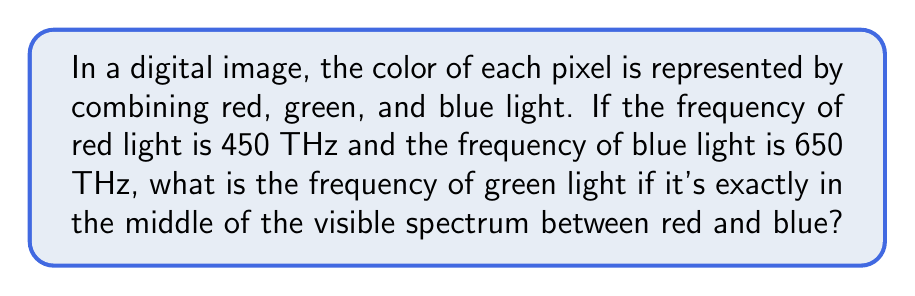What is the answer to this math problem? Let's approach this step-by-step:

1) First, we need to understand that the visible light spectrum ranges from about 400 THz to 790 THz.

2) We're given that:
   Red light frequency = 450 THz
   Blue light frequency = 650 THz

3) To find the frequency of green light that's exactly in the middle, we need to calculate the average of the red and blue light frequencies.

4) The formula for the average of two numbers is:
   $$ \text{Average} = \frac{\text{Sum of numbers}}{\text{Number of numbers}} $$

5) In this case:
   $$ \text{Green frequency} = \frac{\text{Red frequency} + \text{Blue frequency}}{2} $$

6) Let's substitute the values:
   $$ \text{Green frequency} = \frac{450 \text{ THz} + 650 \text{ THz}}{2} $$

7) Now, let's calculate:
   $$ \text{Green frequency} = \frac{1100 \text{ THz}}{2} = 550 \text{ THz} $$

Therefore, the frequency of green light that's exactly in the middle of the spectrum between red and blue is 550 THz.
Answer: 550 THz 